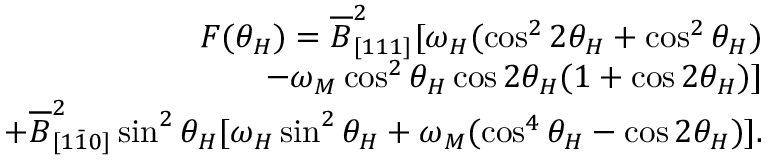Convert formula to latex. <formula><loc_0><loc_0><loc_500><loc_500>\begin{array} { r } { F ( \theta _ { H } ) = \overline { B } _ { [ 1 1 1 ] } ^ { 2 } [ \omega _ { H } ( \cos ^ { 2 } { 2 \theta _ { H } } + \cos ^ { 2 } { \theta _ { H } } ) } \\ { - \omega _ { M } \cos ^ { 2 } { \theta _ { H } } \cos { 2 \theta _ { H } } ( 1 + \cos { 2 \theta _ { H } } ) ] } \\ { + \overline { B } _ { [ 1 \bar { 1 } 0 ] } ^ { 2 } \sin ^ { 2 } { \theta _ { H } } [ \omega _ { H } \sin ^ { 2 } { \theta _ { H } } + \omega _ { M } ( \cos ^ { 4 } { \theta _ { H } } - \cos { 2 \theta _ { H } } ) ] . } \end{array}</formula> 